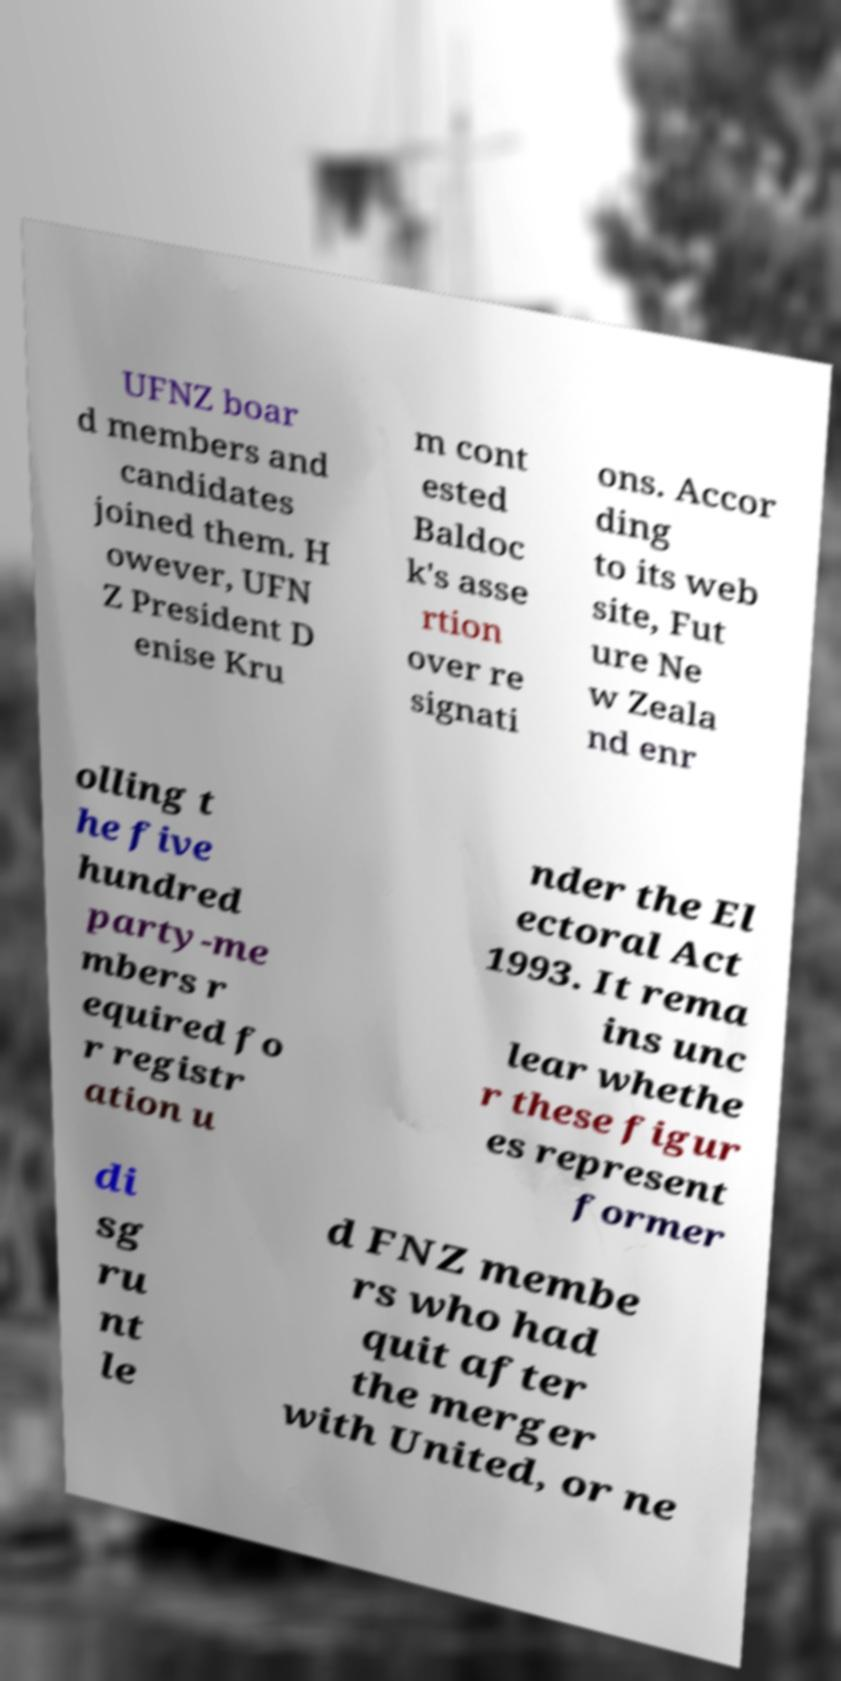For documentation purposes, I need the text within this image transcribed. Could you provide that? UFNZ boar d members and candidates joined them. H owever, UFN Z President D enise Kru m cont ested Baldoc k's asse rtion over re signati ons. Accor ding to its web site, Fut ure Ne w Zeala nd enr olling t he five hundred party-me mbers r equired fo r registr ation u nder the El ectoral Act 1993. It rema ins unc lear whethe r these figur es represent former di sg ru nt le d FNZ membe rs who had quit after the merger with United, or ne 